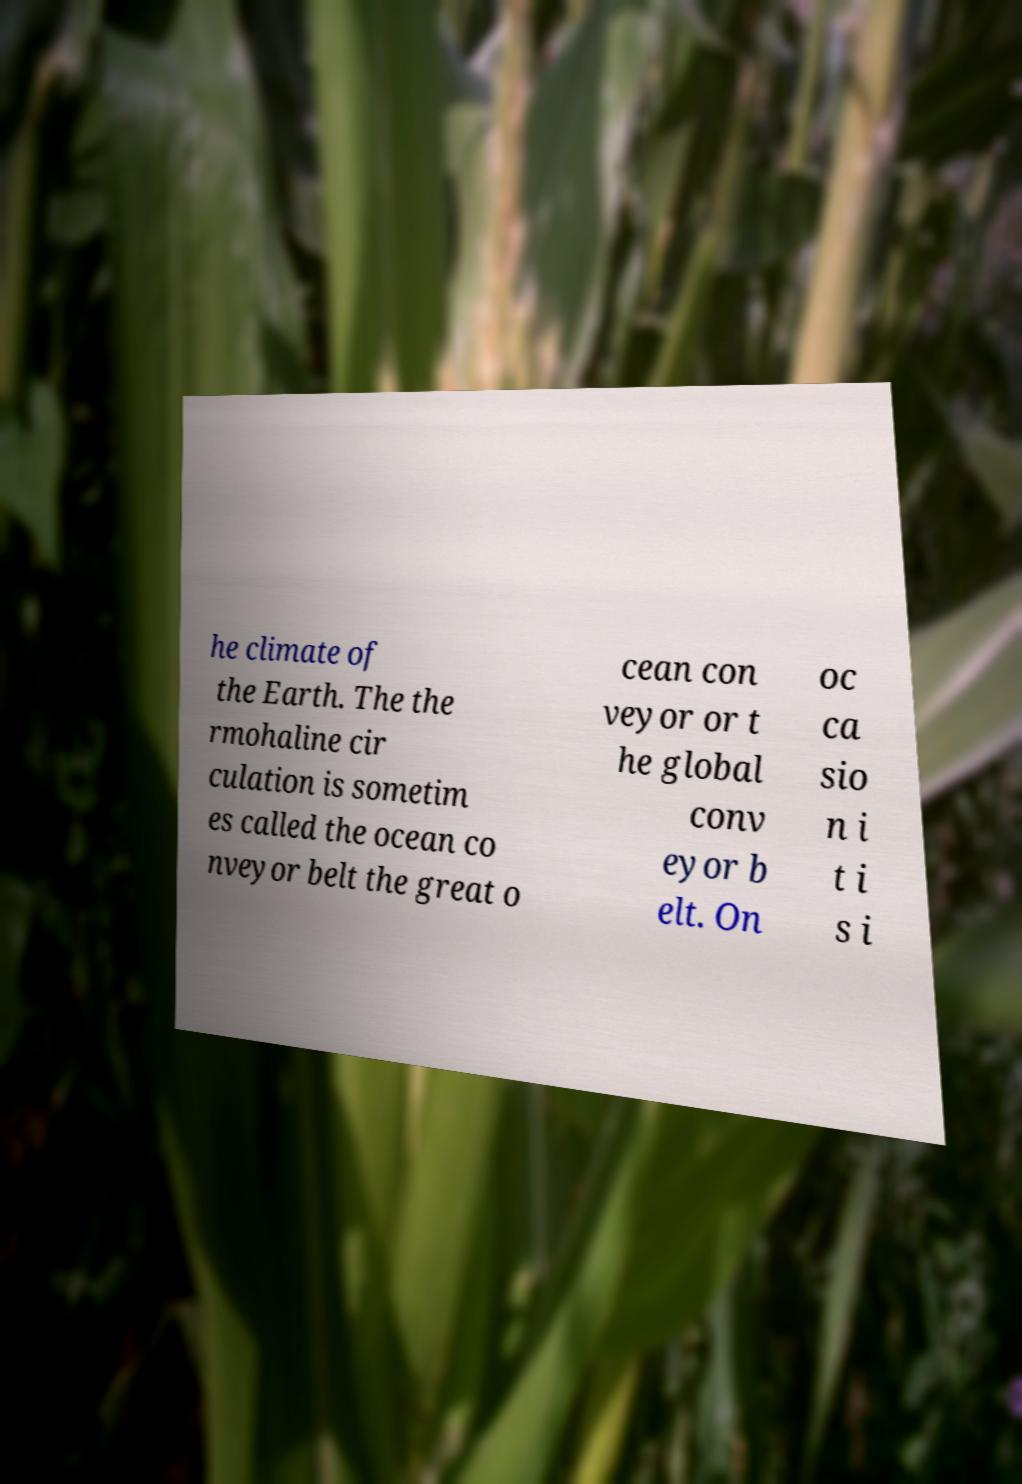I need the written content from this picture converted into text. Can you do that? he climate of the Earth. The the rmohaline cir culation is sometim es called the ocean co nveyor belt the great o cean con veyor or t he global conv eyor b elt. On oc ca sio n i t i s i 